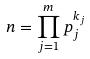<formula> <loc_0><loc_0><loc_500><loc_500>n = \prod _ { j = 1 } ^ { m } p _ { j } ^ { k _ { j } }</formula> 